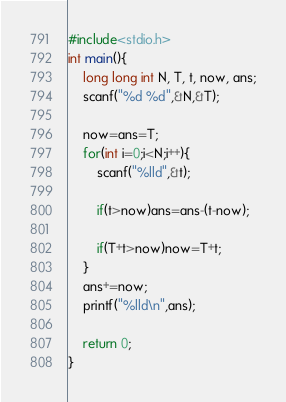<code> <loc_0><loc_0><loc_500><loc_500><_C_>#include<stdio.h>
int main(){
    long long int N, T, t, now, ans;
    scanf("%d %d",&N,&T);
    
    now=ans=T;
    for(int i=0;i<N;i++){
        scanf("%lld",&t);

        if(t>now)ans=ans-(t-now);

        if(T+t>now)now=T+t;
    }
    ans+=now;
    printf("%lld\n",ans);

    return 0;
}</code> 